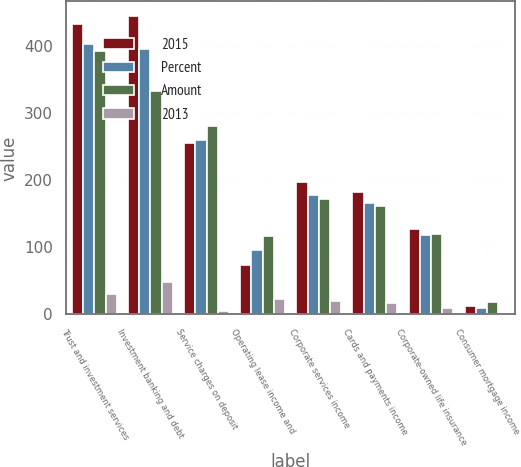Convert chart. <chart><loc_0><loc_0><loc_500><loc_500><stacked_bar_chart><ecel><fcel>Trust and investment services<fcel>Investment banking and debt<fcel>Service charges on deposit<fcel>Operating lease income and<fcel>Corporate services income<fcel>Cards and payments income<fcel>Corporate-owned life insurance<fcel>Consumer mortgage income<nl><fcel>2015<fcel>433<fcel>445<fcel>256<fcel>73<fcel>198<fcel>183<fcel>127<fcel>12<nl><fcel>Percent<fcel>403<fcel>397<fcel>261<fcel>96<fcel>178<fcel>166<fcel>118<fcel>10<nl><fcel>Amount<fcel>393<fcel>333<fcel>281<fcel>117<fcel>172<fcel>162<fcel>120<fcel>19<nl><fcel>2013<fcel>30<fcel>48<fcel>5<fcel>23<fcel>20<fcel>17<fcel>9<fcel>2<nl></chart> 